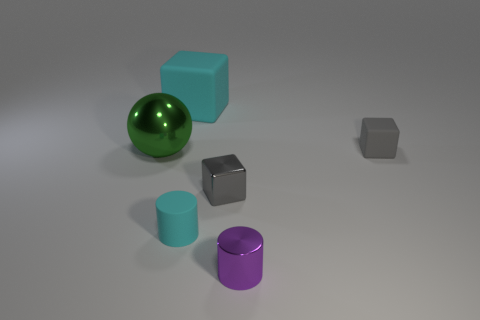Is there a small cyan matte object?
Keep it short and to the point. Yes. Do the cyan thing right of the large rubber cube and the green ball have the same material?
Provide a short and direct response. No. Is there a green shiny object of the same shape as the tiny purple metallic object?
Offer a very short reply. No. Is the number of cyan matte cylinders behind the big cyan cube the same as the number of rubber things?
Make the answer very short. No. What material is the tiny cylinder on the right side of the matte object in front of the gray matte thing?
Give a very brief answer. Metal. There is a gray matte thing; what shape is it?
Ensure brevity in your answer.  Cube. Is the number of tiny gray shiny things behind the big rubber object the same as the number of small gray things on the left side of the purple shiny cylinder?
Your answer should be compact. No. There is a tiny cube that is behind the shiny ball; is it the same color as the tiny block left of the gray rubber object?
Your answer should be very brief. Yes. Are there more tiny matte objects that are behind the large green sphere than big yellow cubes?
Provide a short and direct response. Yes. There is a tiny purple thing that is the same material as the sphere; what is its shape?
Your answer should be compact. Cylinder. 